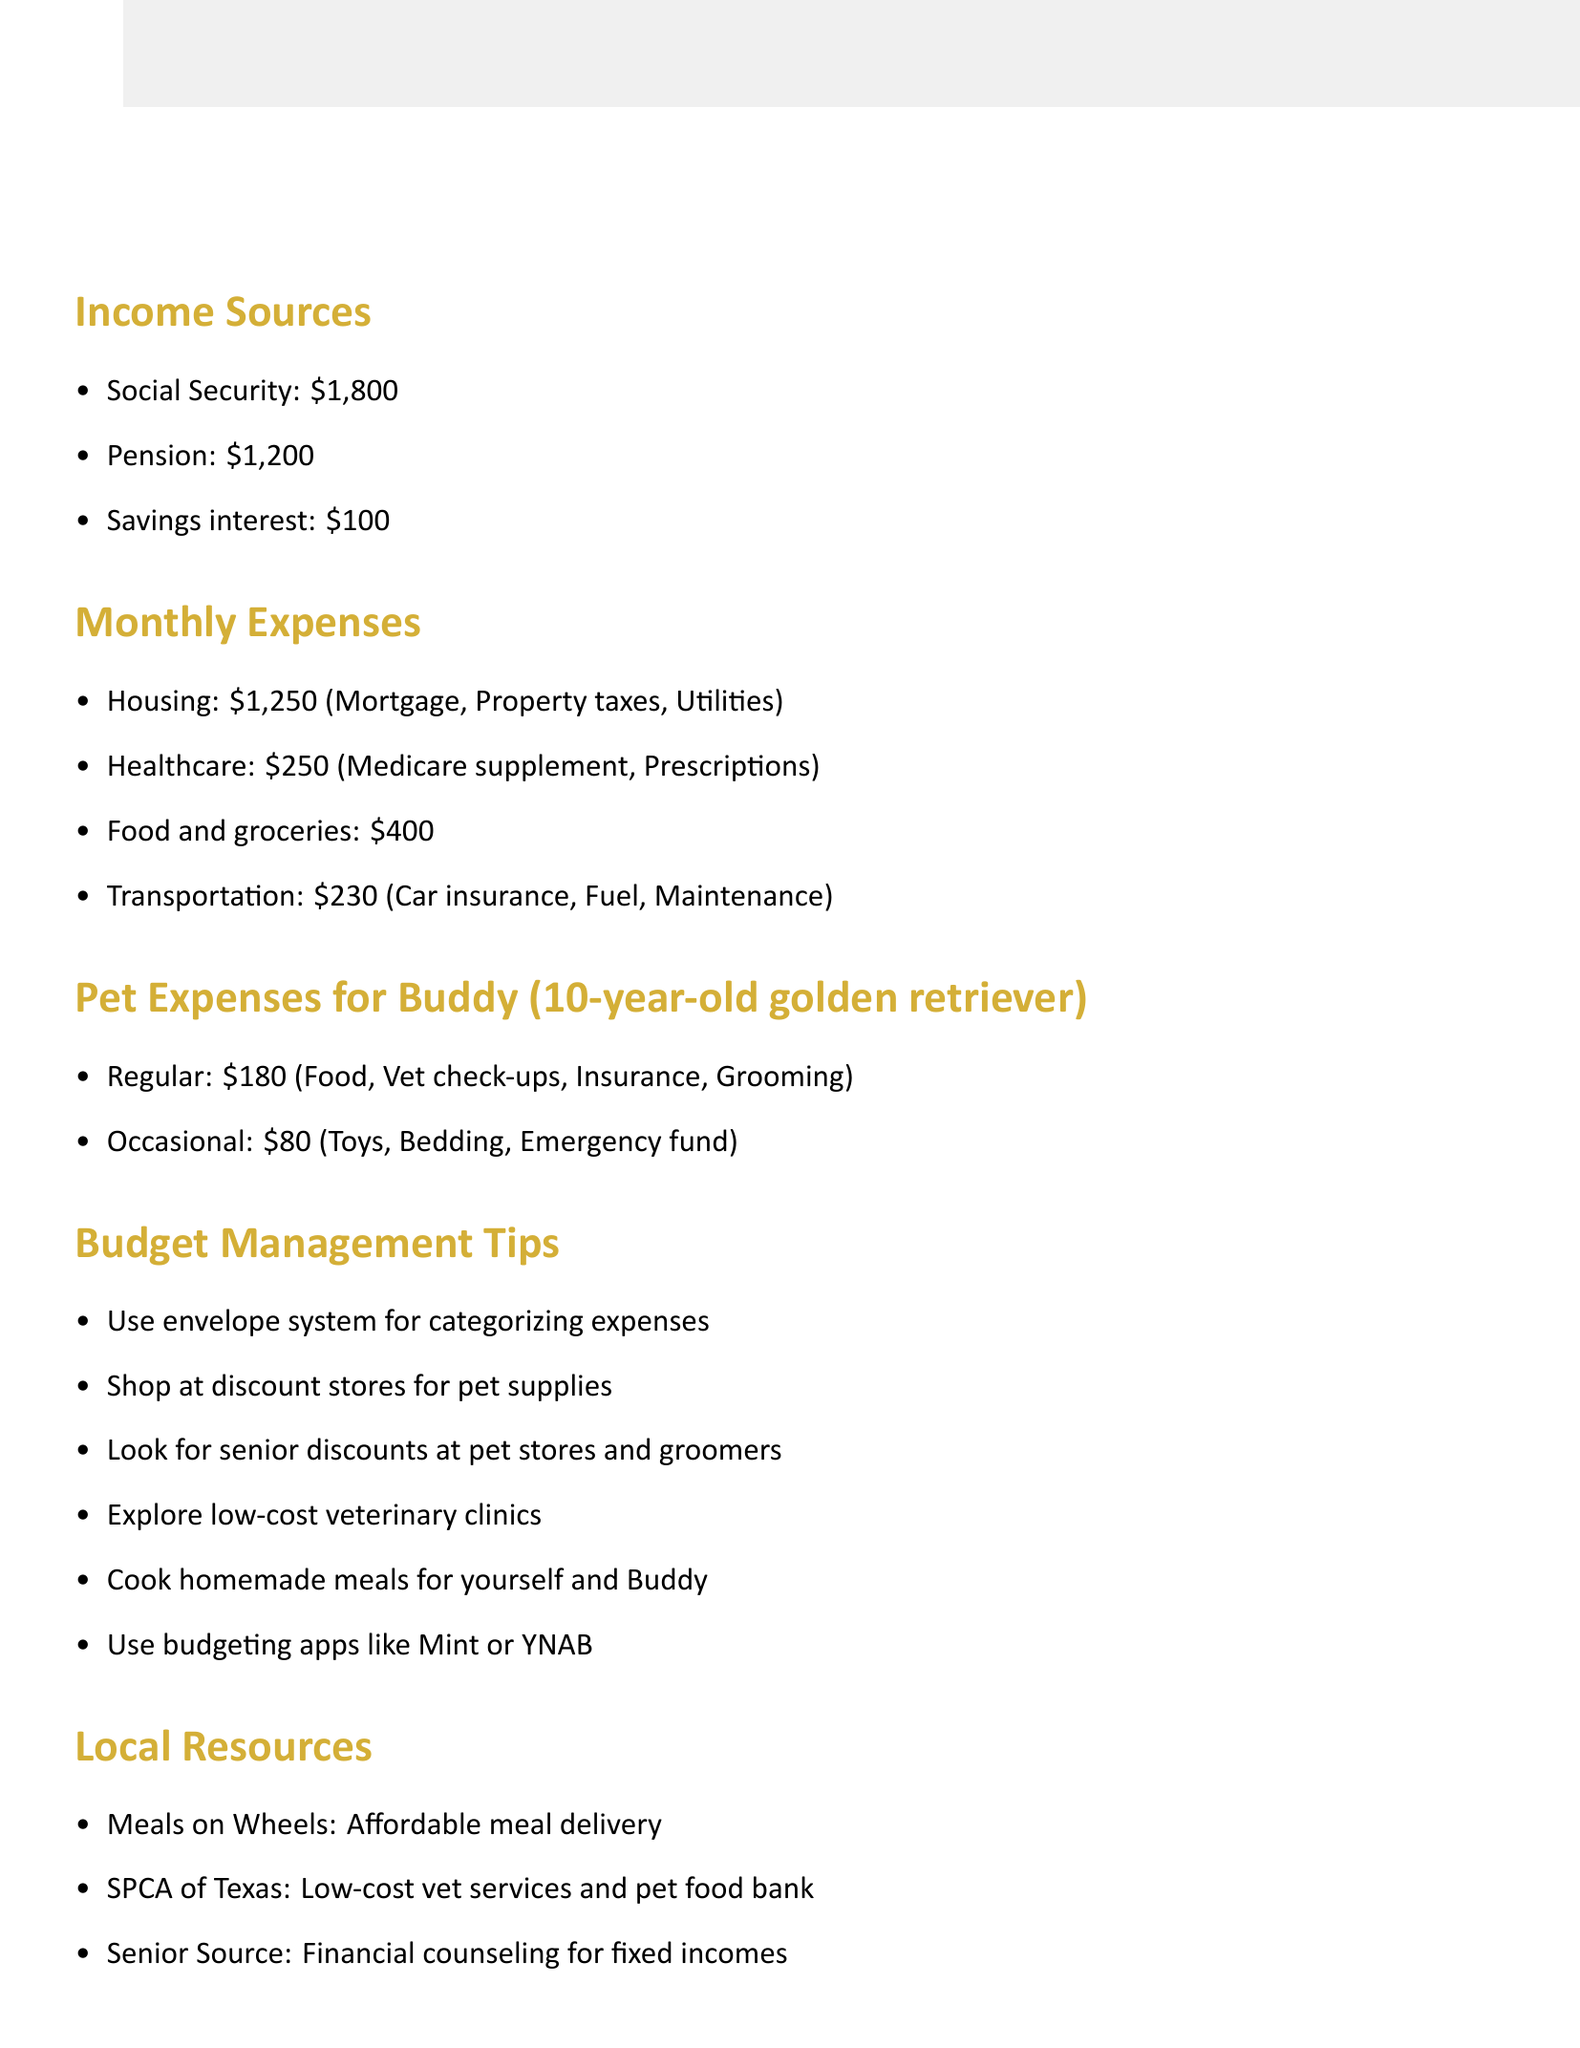what is the total amount from Social Security? The document lists Social Security as providing an income of $1,800.
Answer: $1,800 how much are monthly healthcare expenses? The document shows that healthcare expenses total $250.
Answer: $250 what is the total amount for Buddy's regular pet expenses? The regular pet expenses are detailed in the document and total $180.
Answer: $180 what type of pet does Harold have? The document states that Harold has a golden retriever named Buddy.
Answer: golden retriever which resource provides meal delivery for seniors? The document mentions Meals on Wheels as a resource for affordable meal delivery.
Answer: Meals on Wheels how much is the total fixed income Harold receives monthly? The total fixed income is the sum of Social Security, Pension, and Savings interest, which is $1,800 + $1,200 + $100 = $3,100.
Answer: $3,100 what is one of the budget management tips mentioned? The document suggests using an envelope system for categorizing expenses as one of the tips.
Answer: use envelope system how much is set aside for emergencies in pet expenses? The occasional expenses for unexpected vet bills are specified as $50 in the document.
Answer: $50 what is a future consideration for Harold? One future consideration mentioned is to plan for potential increases in healthcare costs.
Answer: plan for potential increases in healthcare costs 